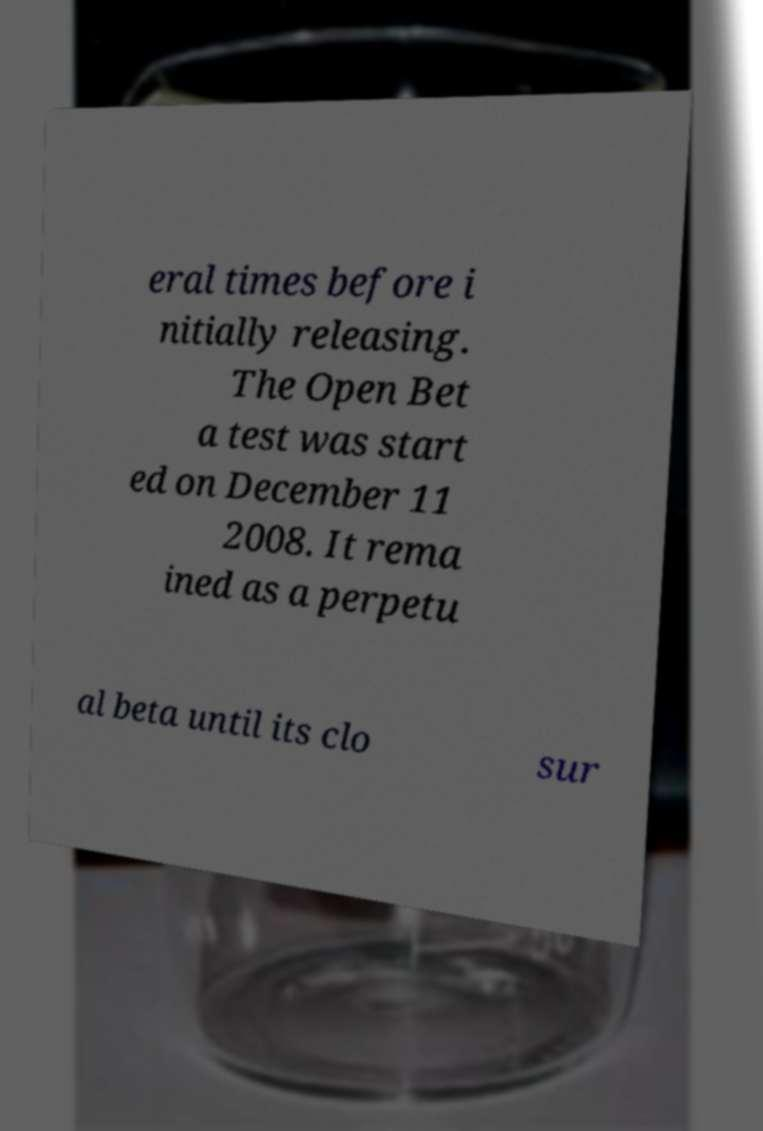Please identify and transcribe the text found in this image. eral times before i nitially releasing. The Open Bet a test was start ed on December 11 2008. It rema ined as a perpetu al beta until its clo sur 